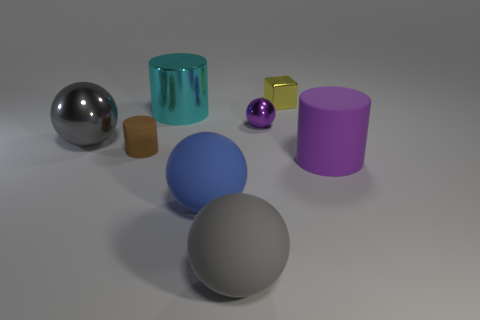There is a matte cylinder that is left of the large cylinder that is right of the small yellow cube; are there any small metal objects that are right of it?
Give a very brief answer. Yes. What is the size of the yellow thing?
Give a very brief answer. Small. How many other things are the same color as the tiny rubber object?
Offer a terse response. 0. Does the gray object left of the cyan shiny cylinder have the same shape as the blue object?
Keep it short and to the point. Yes. What is the color of the other large rubber thing that is the same shape as the blue object?
Offer a terse response. Gray. What is the size of the purple thing that is the same shape as the blue matte thing?
Your response must be concise. Small. The cylinder that is in front of the gray metallic object and to the left of the large matte cylinder is made of what material?
Provide a short and direct response. Rubber. There is a shiny ball right of the large blue rubber sphere; is its color the same as the large matte cylinder?
Your answer should be compact. Yes. Do the big rubber cylinder and the large cylinder that is left of the yellow shiny cube have the same color?
Provide a succinct answer. No. Are there any small metal things in front of the yellow metallic thing?
Ensure brevity in your answer.  Yes. 